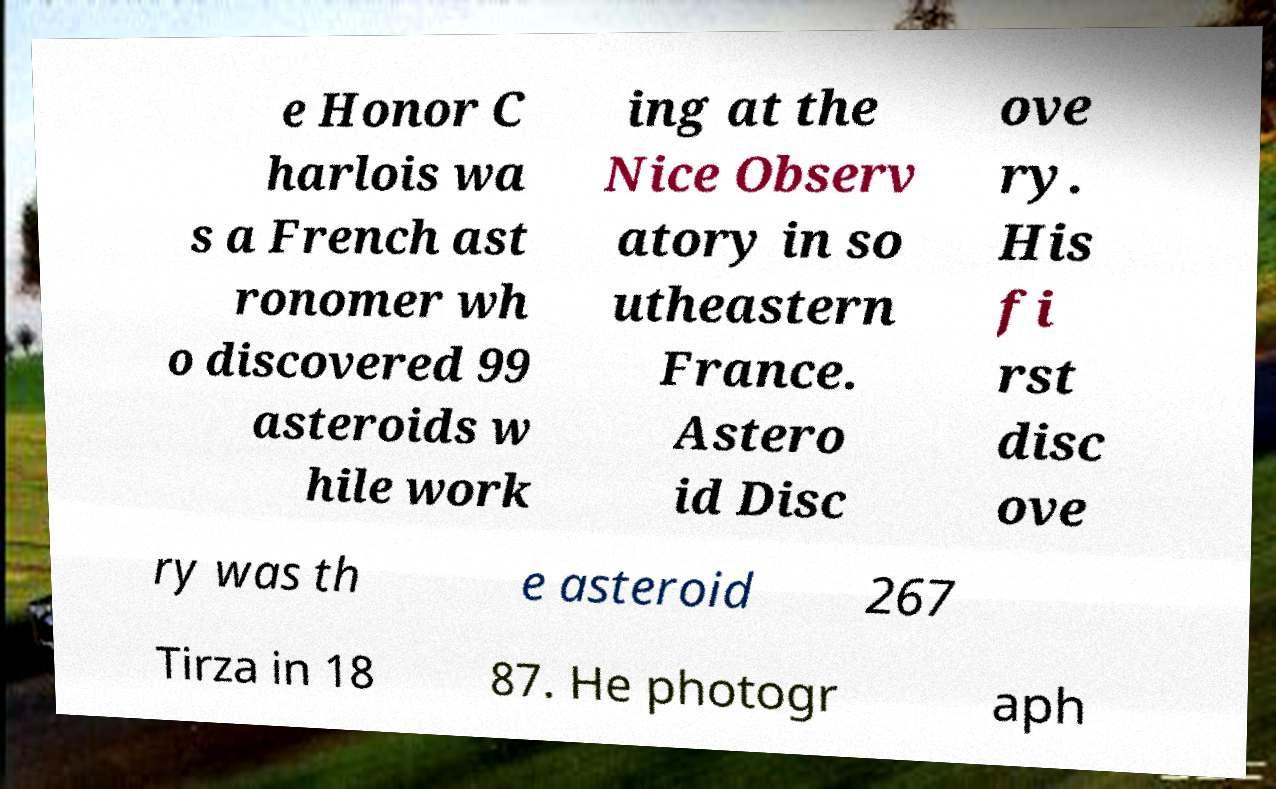What messages or text are displayed in this image? I need them in a readable, typed format. e Honor C harlois wa s a French ast ronomer wh o discovered 99 asteroids w hile work ing at the Nice Observ atory in so utheastern France. Astero id Disc ove ry. His fi rst disc ove ry was th e asteroid 267 Tirza in 18 87. He photogr aph 